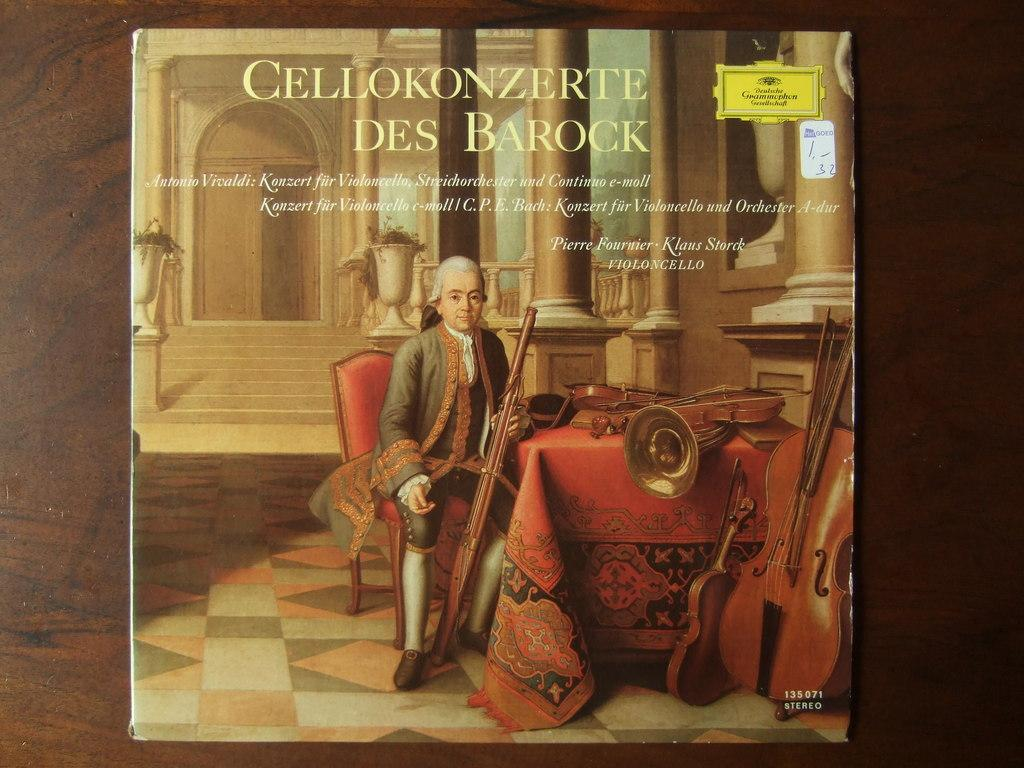<image>
Relay a brief, clear account of the picture shown. An album by Cellokonzerte Des Darock has a man on the cover. 